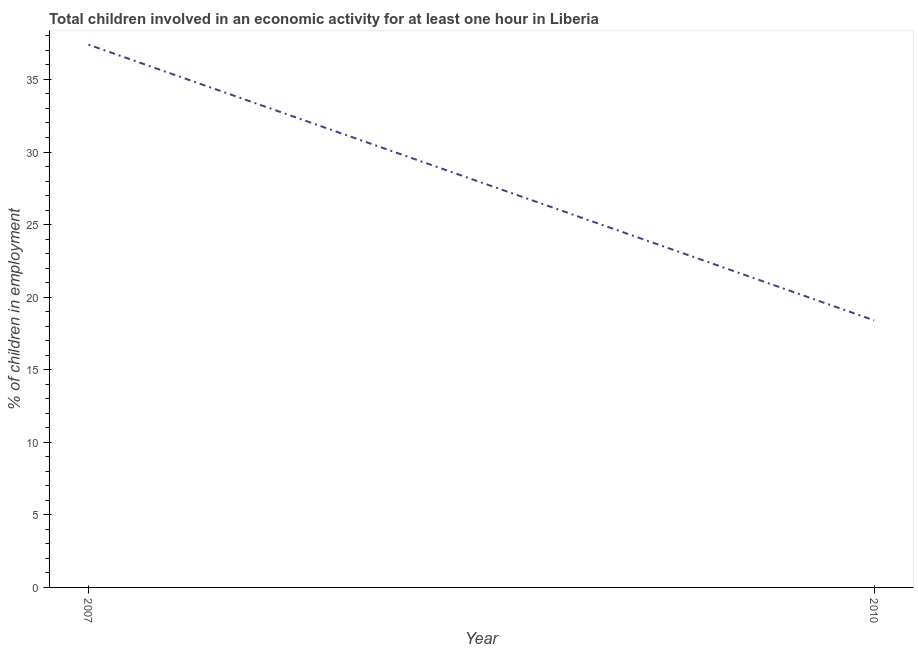Across all years, what is the maximum percentage of children in employment?
Keep it short and to the point. 37.4. In which year was the percentage of children in employment minimum?
Keep it short and to the point. 2010. What is the sum of the percentage of children in employment?
Your answer should be very brief. 55.8. What is the average percentage of children in employment per year?
Ensure brevity in your answer.  27.9. What is the median percentage of children in employment?
Ensure brevity in your answer.  27.9. Do a majority of the years between 2010 and 2007 (inclusive) have percentage of children in employment greater than 27 %?
Ensure brevity in your answer.  No. What is the ratio of the percentage of children in employment in 2007 to that in 2010?
Ensure brevity in your answer.  2.03. Is the percentage of children in employment in 2007 less than that in 2010?
Make the answer very short. No. How many lines are there?
Provide a succinct answer. 1. How many years are there in the graph?
Ensure brevity in your answer.  2. Are the values on the major ticks of Y-axis written in scientific E-notation?
Your answer should be compact. No. Does the graph contain any zero values?
Provide a succinct answer. No. Does the graph contain grids?
Ensure brevity in your answer.  No. What is the title of the graph?
Offer a terse response. Total children involved in an economic activity for at least one hour in Liberia. What is the label or title of the Y-axis?
Your answer should be compact. % of children in employment. What is the % of children in employment in 2007?
Keep it short and to the point. 37.4. What is the ratio of the % of children in employment in 2007 to that in 2010?
Your response must be concise. 2.03. 